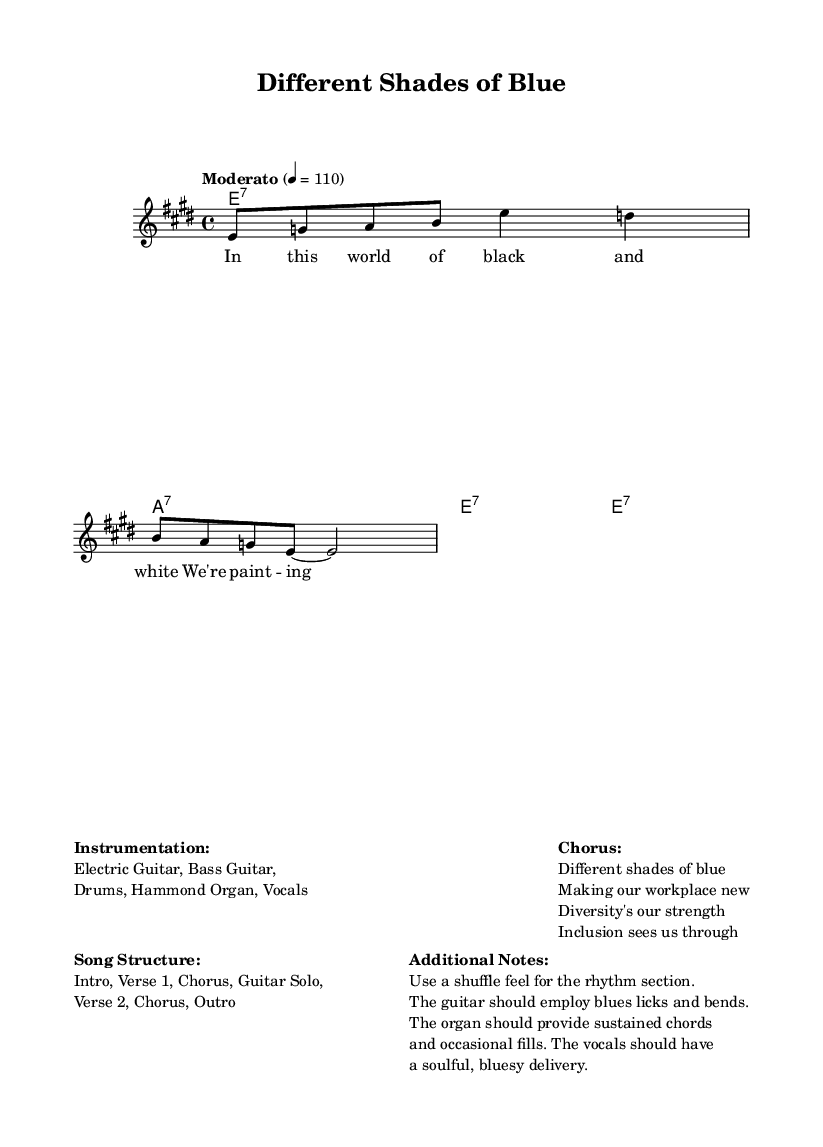What is the key signature of this music? The key signature shows E major, which has four sharps.
Answer: E major What is the time signature of the piece? The time signature is indicated as 4/4, meaning there are four beats per measure.
Answer: 4/4 What is the tempo marking for the piece? The tempo marking states "Moderato" with a tempo of quarter note equals 110 beats per minute.
Answer: Moderato 4 = 110 How many verses are in the song structure? The song structure outlines two verses: Verse 1 and Verse 2.
Answer: 2 What instruments are mentioned for this piece? The instrumentation includes Electric Guitar, Bass Guitar, Drums, Hammond Organ, and Vocals.
Answer: Electric Guitar, Bass Guitar, Drums, Hammond Organ, Vocals What lyrical theme is addressed in the chorus? The chorus emphasizes the importance of diverse perspectives and how they enhance the workplace.
Answer: Diversity's our strength How should the rhythm section be played according to the additional notes? The additional notes recommend using a shuffle feel for the rhythm section, which is characteristic of the blues style.
Answer: Shuffle feel 